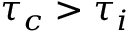<formula> <loc_0><loc_0><loc_500><loc_500>\tau _ { c } > \tau _ { i }</formula> 